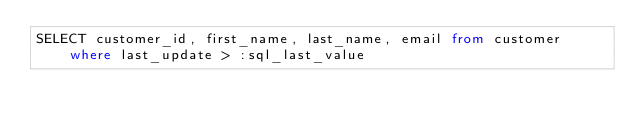Convert code to text. <code><loc_0><loc_0><loc_500><loc_500><_SQL_>SELECT customer_id, first_name, last_name, email from customer where last_update > :sql_last_value
</code> 